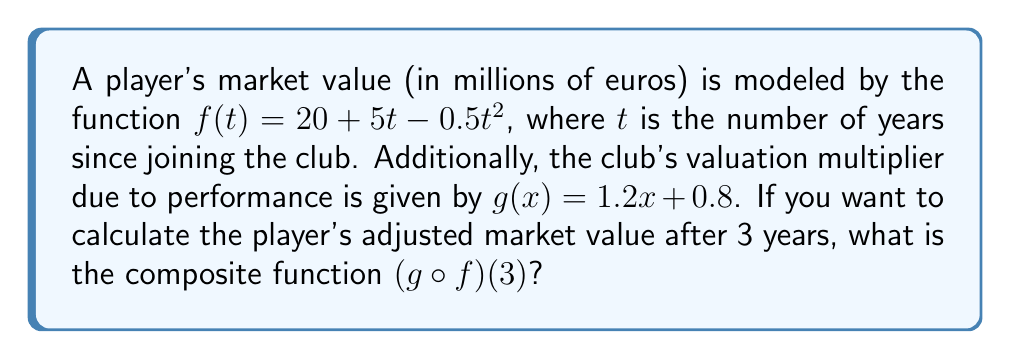Give your solution to this math problem. To solve this problem, we need to follow these steps:

1. First, we need to find $f(3)$, which represents the player's market value after 3 years:
   $$f(3) = 20 + 5(3) - 0.5(3)^2$$
   $$f(3) = 20 + 15 - 0.5(9)$$
   $$f(3) = 35 - 4.5 = 30.5$$

2. Now that we have $f(3)$, we need to apply the club's valuation multiplier function $g(x)$ to this value:
   $$(g \circ f)(3) = g(f(3)) = g(30.5)$$

3. Calculate $g(30.5)$:
   $$g(30.5) = 1.2(30.5) + 0.8$$
   $$g(30.5) = 36.6 + 0.8 = 37.4$$

Therefore, the player's adjusted market value after 3 years, accounting for the club's performance multiplier, is 37.4 million euros.
Answer: 37.4 million euros 